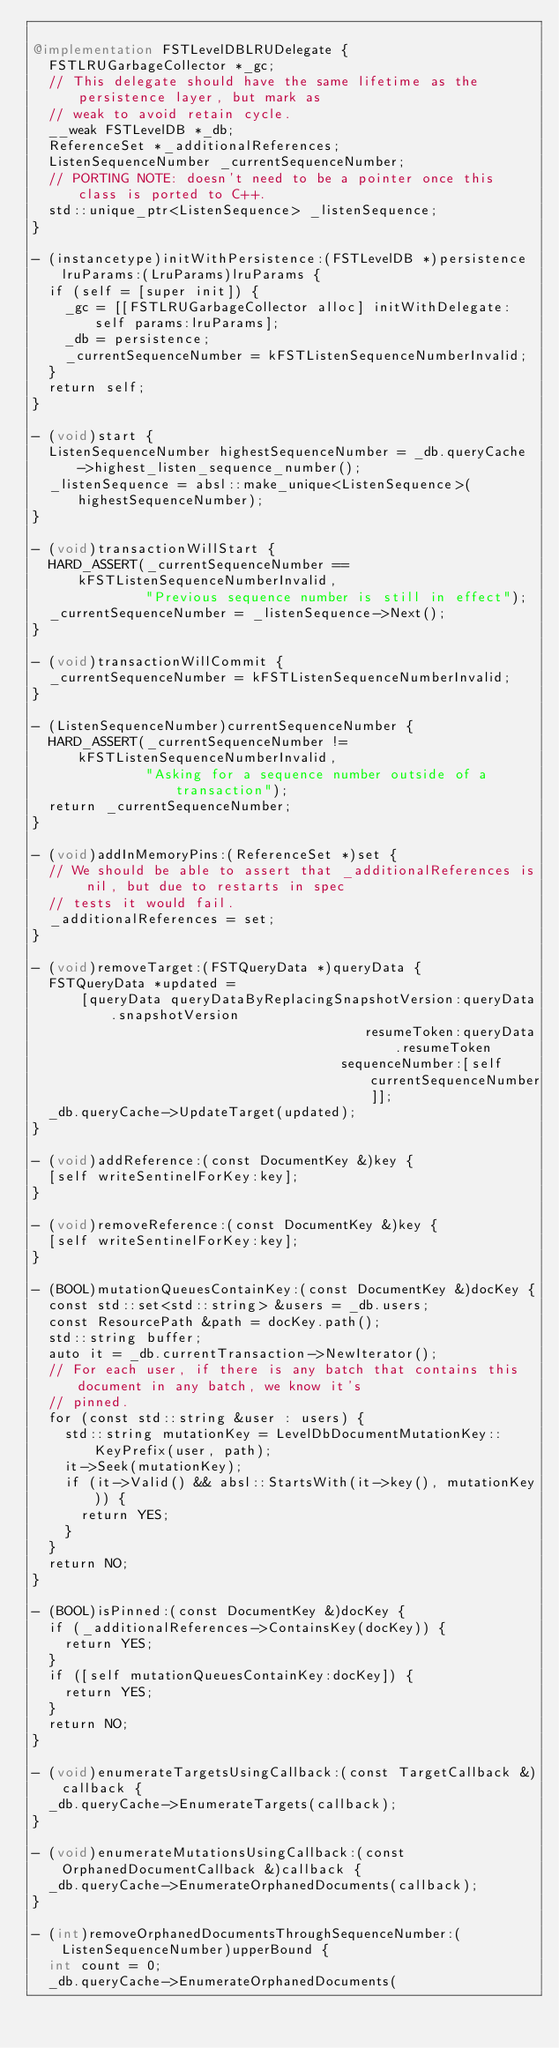<code> <loc_0><loc_0><loc_500><loc_500><_ObjectiveC_>
@implementation FSTLevelDBLRUDelegate {
  FSTLRUGarbageCollector *_gc;
  // This delegate should have the same lifetime as the persistence layer, but mark as
  // weak to avoid retain cycle.
  __weak FSTLevelDB *_db;
  ReferenceSet *_additionalReferences;
  ListenSequenceNumber _currentSequenceNumber;
  // PORTING NOTE: doesn't need to be a pointer once this class is ported to C++.
  std::unique_ptr<ListenSequence> _listenSequence;
}

- (instancetype)initWithPersistence:(FSTLevelDB *)persistence lruParams:(LruParams)lruParams {
  if (self = [super init]) {
    _gc = [[FSTLRUGarbageCollector alloc] initWithDelegate:self params:lruParams];
    _db = persistence;
    _currentSequenceNumber = kFSTListenSequenceNumberInvalid;
  }
  return self;
}

- (void)start {
  ListenSequenceNumber highestSequenceNumber = _db.queryCache->highest_listen_sequence_number();
  _listenSequence = absl::make_unique<ListenSequence>(highestSequenceNumber);
}

- (void)transactionWillStart {
  HARD_ASSERT(_currentSequenceNumber == kFSTListenSequenceNumberInvalid,
              "Previous sequence number is still in effect");
  _currentSequenceNumber = _listenSequence->Next();
}

- (void)transactionWillCommit {
  _currentSequenceNumber = kFSTListenSequenceNumberInvalid;
}

- (ListenSequenceNumber)currentSequenceNumber {
  HARD_ASSERT(_currentSequenceNumber != kFSTListenSequenceNumberInvalid,
              "Asking for a sequence number outside of a transaction");
  return _currentSequenceNumber;
}

- (void)addInMemoryPins:(ReferenceSet *)set {
  // We should be able to assert that _additionalReferences is nil, but due to restarts in spec
  // tests it would fail.
  _additionalReferences = set;
}

- (void)removeTarget:(FSTQueryData *)queryData {
  FSTQueryData *updated =
      [queryData queryDataByReplacingSnapshotVersion:queryData.snapshotVersion
                                         resumeToken:queryData.resumeToken
                                      sequenceNumber:[self currentSequenceNumber]];
  _db.queryCache->UpdateTarget(updated);
}

- (void)addReference:(const DocumentKey &)key {
  [self writeSentinelForKey:key];
}

- (void)removeReference:(const DocumentKey &)key {
  [self writeSentinelForKey:key];
}

- (BOOL)mutationQueuesContainKey:(const DocumentKey &)docKey {
  const std::set<std::string> &users = _db.users;
  const ResourcePath &path = docKey.path();
  std::string buffer;
  auto it = _db.currentTransaction->NewIterator();
  // For each user, if there is any batch that contains this document in any batch, we know it's
  // pinned.
  for (const std::string &user : users) {
    std::string mutationKey = LevelDbDocumentMutationKey::KeyPrefix(user, path);
    it->Seek(mutationKey);
    if (it->Valid() && absl::StartsWith(it->key(), mutationKey)) {
      return YES;
    }
  }
  return NO;
}

- (BOOL)isPinned:(const DocumentKey &)docKey {
  if (_additionalReferences->ContainsKey(docKey)) {
    return YES;
  }
  if ([self mutationQueuesContainKey:docKey]) {
    return YES;
  }
  return NO;
}

- (void)enumerateTargetsUsingCallback:(const TargetCallback &)callback {
  _db.queryCache->EnumerateTargets(callback);
}

- (void)enumerateMutationsUsingCallback:(const OrphanedDocumentCallback &)callback {
  _db.queryCache->EnumerateOrphanedDocuments(callback);
}

- (int)removeOrphanedDocumentsThroughSequenceNumber:(ListenSequenceNumber)upperBound {
  int count = 0;
  _db.queryCache->EnumerateOrphanedDocuments(</code> 